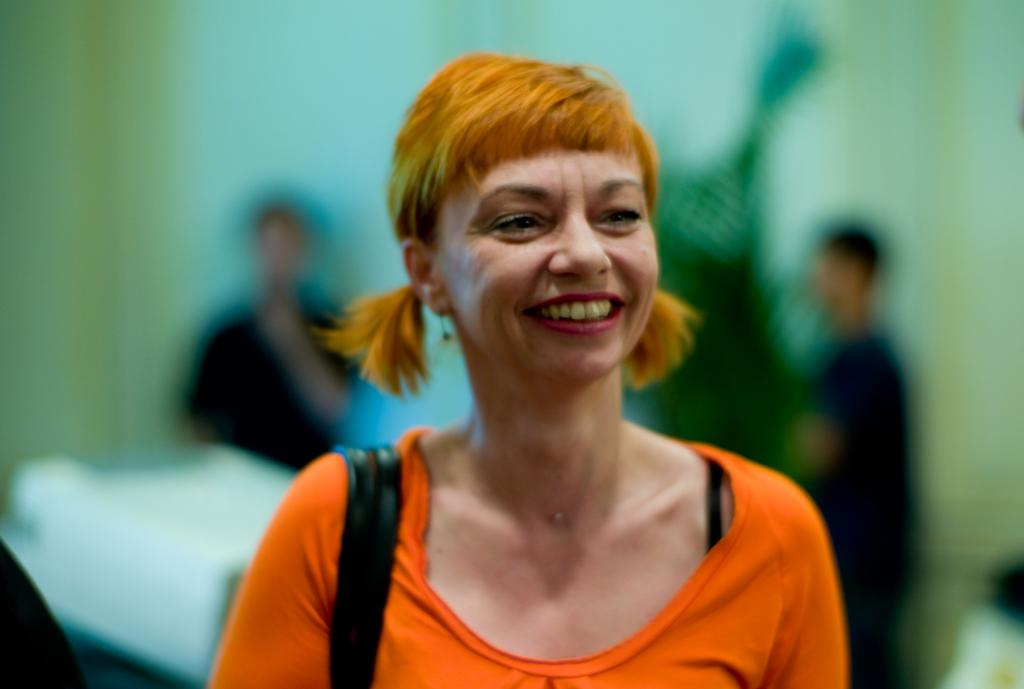Who is present in the image? There is a woman in the image. What is the woman's facial expression? The woman is smiling. Can you describe the background of the image? The background of the image is blurry. What type of tax can be seen in the image? There is no tax present in the image; it features a woman with a smile and a blurry background. How many sides does the square have in the image? There is no square present in the image. 